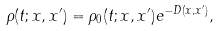Convert formula to latex. <formula><loc_0><loc_0><loc_500><loc_500>\rho ( t ; { x } , { x } ^ { \prime } ) = \rho _ { 0 } ( t ; { x } , { x } ^ { \prime } ) e ^ { - D ( { x } , { x } ^ { \prime } ) } ,</formula> 